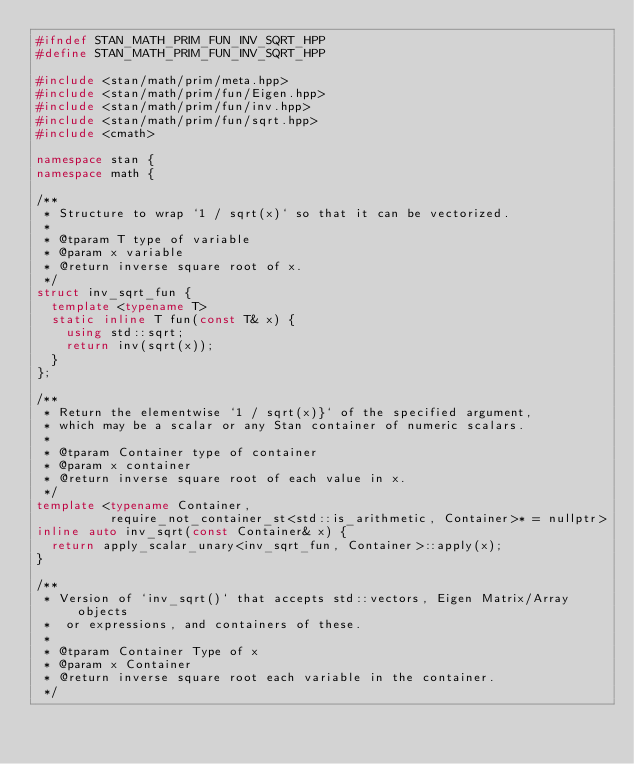Convert code to text. <code><loc_0><loc_0><loc_500><loc_500><_C++_>#ifndef STAN_MATH_PRIM_FUN_INV_SQRT_HPP
#define STAN_MATH_PRIM_FUN_INV_SQRT_HPP

#include <stan/math/prim/meta.hpp>
#include <stan/math/prim/fun/Eigen.hpp>
#include <stan/math/prim/fun/inv.hpp>
#include <stan/math/prim/fun/sqrt.hpp>
#include <cmath>

namespace stan {
namespace math {

/**
 * Structure to wrap `1 / sqrt(x)` so that it can be vectorized.
 *
 * @tparam T type of variable
 * @param x variable
 * @return inverse square root of x.
 */
struct inv_sqrt_fun {
  template <typename T>
  static inline T fun(const T& x) {
    using std::sqrt;
    return inv(sqrt(x));
  }
};

/**
 * Return the elementwise `1 / sqrt(x)}` of the specified argument,
 * which may be a scalar or any Stan container of numeric scalars.
 *
 * @tparam Container type of container
 * @param x container
 * @return inverse square root of each value in x.
 */
template <typename Container,
          require_not_container_st<std::is_arithmetic, Container>* = nullptr>
inline auto inv_sqrt(const Container& x) {
  return apply_scalar_unary<inv_sqrt_fun, Container>::apply(x);
}

/**
 * Version of `inv_sqrt()` that accepts std::vectors, Eigen Matrix/Array objects
 *  or expressions, and containers of these.
 *
 * @tparam Container Type of x
 * @param x Container
 * @return inverse square root each variable in the container.
 */</code> 